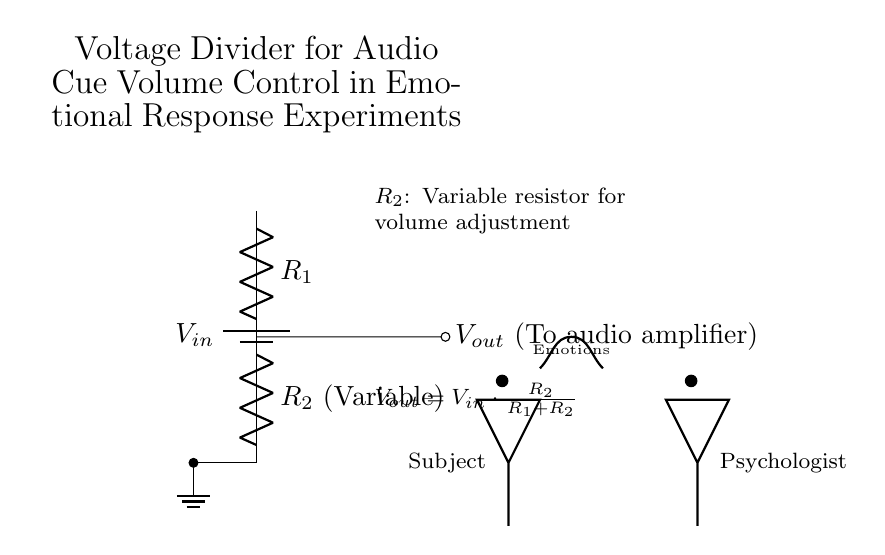What is the function of resistor R2? Resistor R2 is a variable resistor, which allows the adjustment of volume by changing its resistance. This affects the output voltage (volume) sent to the audio amplifier.
Answer: Variable resistor for volume adjustment What is the output voltage formula? The output voltage is given by the formula \(V_{out} = V_{in} \cdot \frac{R_2}{R_1 + R_2}\), which calculates the voltage across R2 in the voltage divider configuration.
Answer: Vout = Vin * (R2 / (R1 + R2)) What does Vout connect to? Vout connects to the audio amplifier, which is used to amplify the audio cue signals during emotional response experiments.
Answer: Audio amplifier What role does R1 play in this circuit? Resistor R1 is a fixed resistor that, together with R2, helps to determine the output voltage level based on the applied input voltage.
Answer: Fixed resistor What would happen if R2 is set to its maximum resistance? If R2 is at its maximum resistance, the output voltage Vout approaches Vin, making the audio cues louder as it allows more voltage to pass through to the amplifier.
Answer: Vout approaches Vin How does the psychologist influence emotional cues in the subject? The psychologist adjusts R2, controlling the volume of audio cues, thereby influencing the subject's emotional responses during the experiment.
Answer: By adjusting R2 